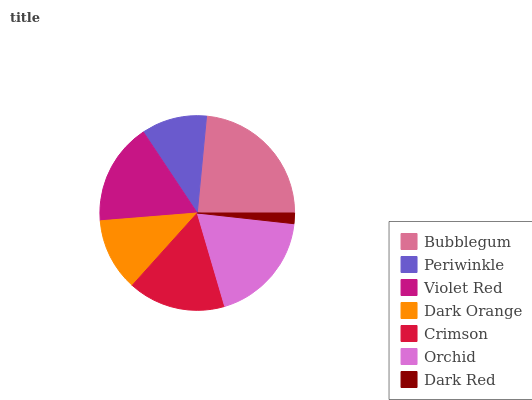Is Dark Red the minimum?
Answer yes or no. Yes. Is Bubblegum the maximum?
Answer yes or no. Yes. Is Periwinkle the minimum?
Answer yes or no. No. Is Periwinkle the maximum?
Answer yes or no. No. Is Bubblegum greater than Periwinkle?
Answer yes or no. Yes. Is Periwinkle less than Bubblegum?
Answer yes or no. Yes. Is Periwinkle greater than Bubblegum?
Answer yes or no. No. Is Bubblegum less than Periwinkle?
Answer yes or no. No. Is Crimson the high median?
Answer yes or no. Yes. Is Crimson the low median?
Answer yes or no. Yes. Is Dark Orange the high median?
Answer yes or no. No. Is Periwinkle the low median?
Answer yes or no. No. 